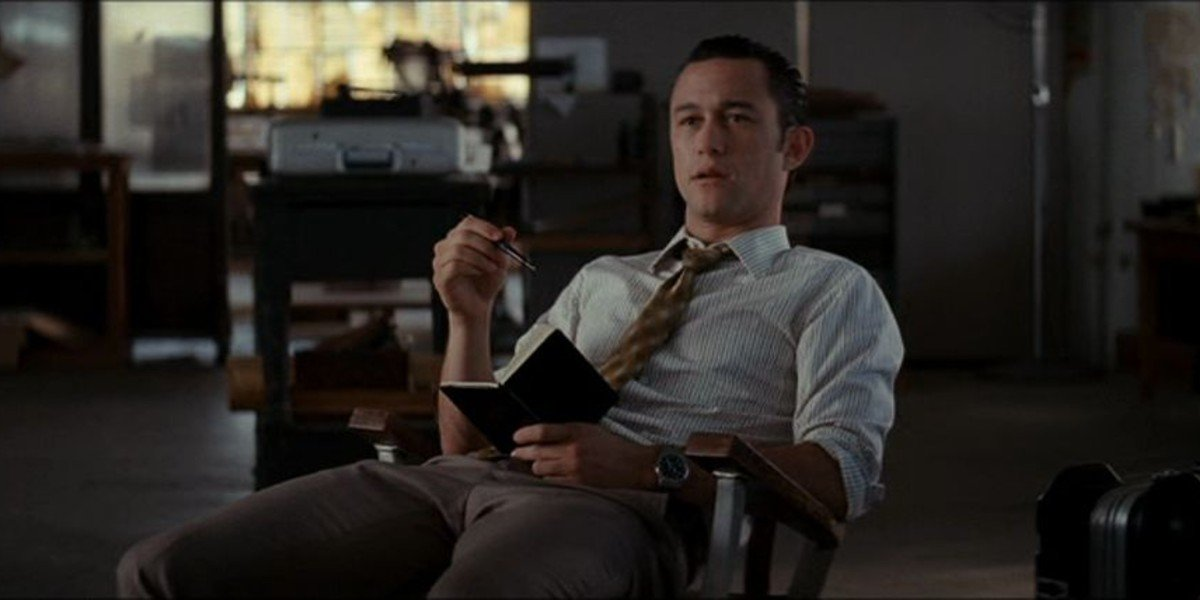If this scene were from a movie, what genre would it belong to? This scene could fit perfectly in a drama or a suspense thriller. The thoughtful expression and professional workplace hint at a storyline involving high-stakes decisions, complex character interactions, and possibly some underlying tension. There is an air of introspection and anticipation that would be right at home in a dramatic or thriller narrative. 